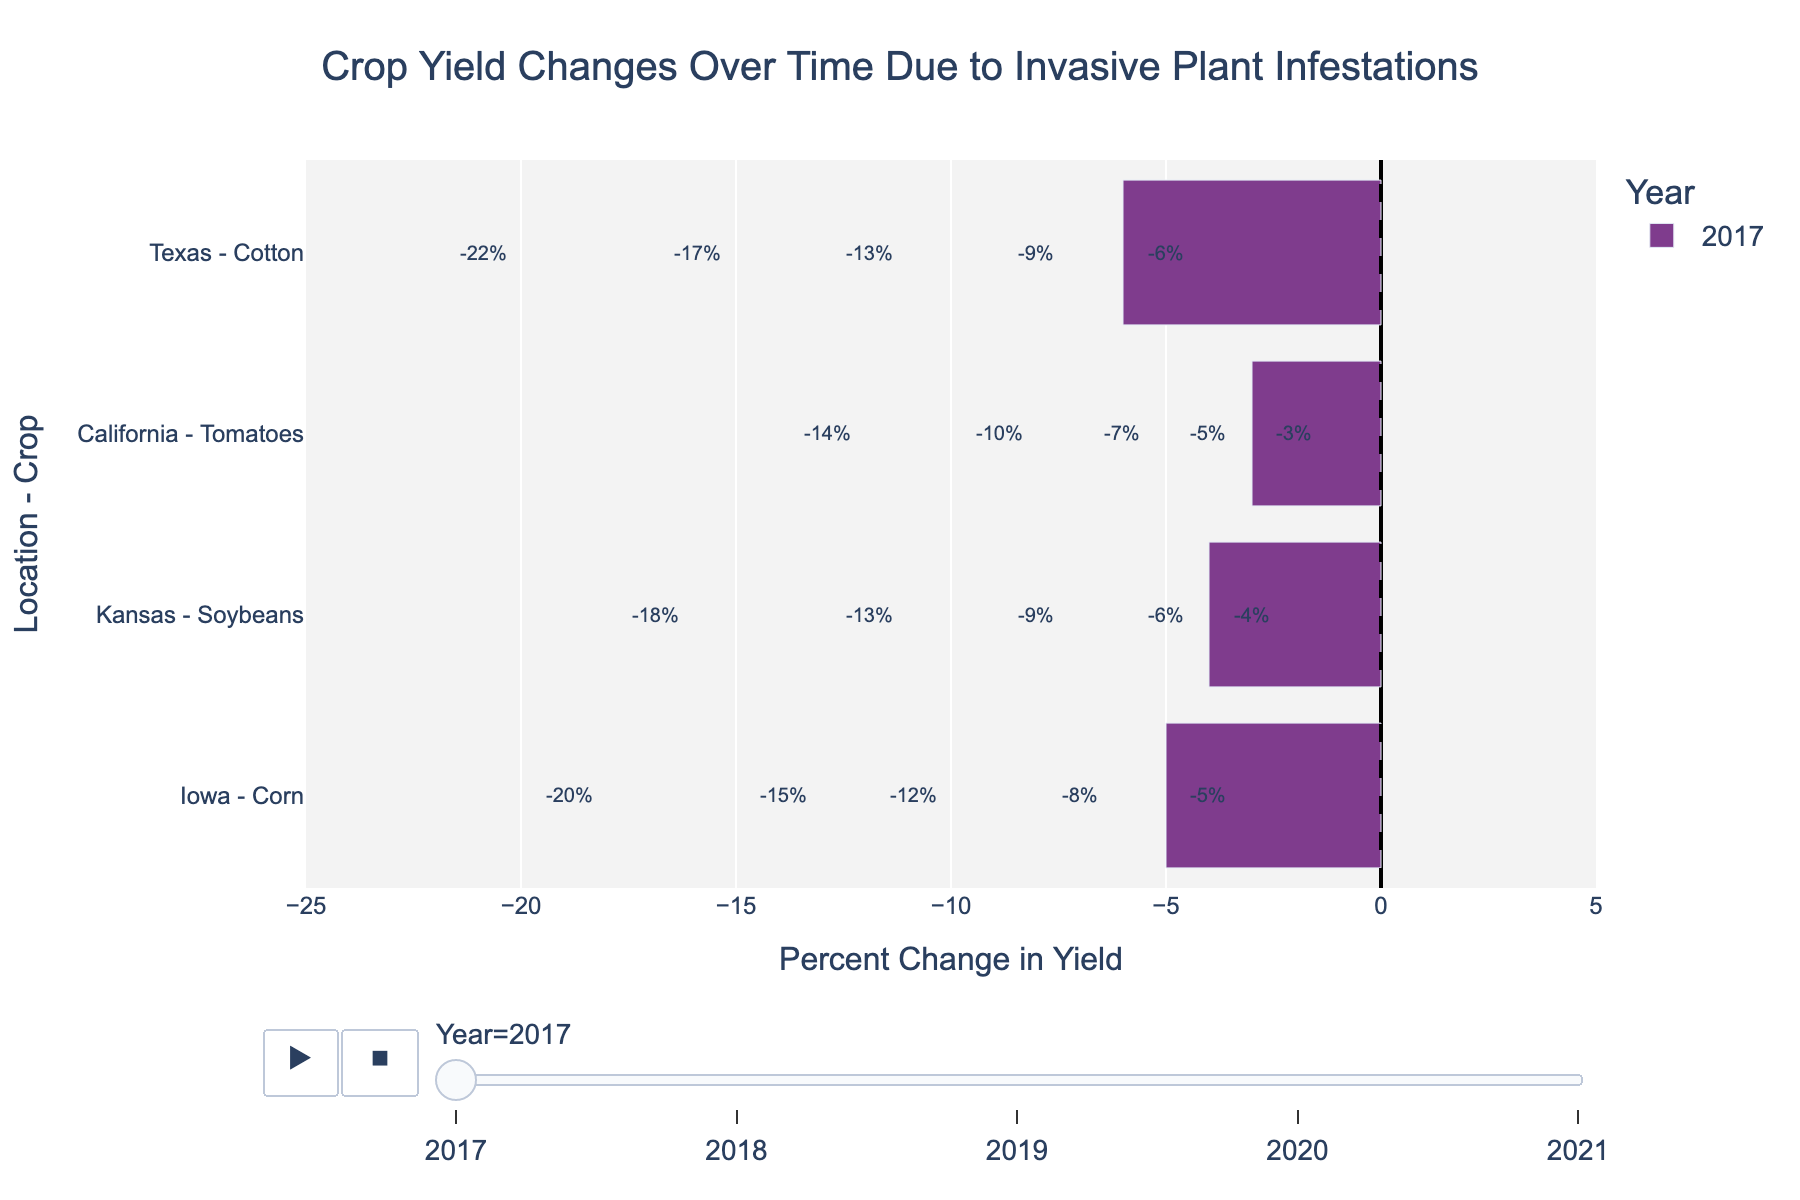What is the average percent change in yield for Iowa Corn between 2017 and 2021? To find the average, add the percent changes for each year and divide by the number of years. (-5) + (-8) + (-12) + (-15) + (-20) = -60. Then divide by 5, which gives -60 / 5 = -12
Answer: -12 Which crop experienced the greatest decline in yield in 2021? In 2021, Texas Cotton had a yield change of -22%, Iowa Corn had -20%, Kansas Soybeans had -18%, and California Tomatoes had -14%. The greatest decline occurred in Texas Cotton with -22%.
Answer: Texas Cotton Compare the percent change in yield for Kansas Soybeans and California Tomatoes in 2019. Which one experienced a larger decline? In 2019, Kansas Soybeans had a percent change in yield of -9%, while California Tomatoes had -7%. Kansas Soybeans experienced a larger decline.
Answer: Kansas Soybeans How much more did Texas Cotton decline compared to Iowa Corn in 2018? In 2018, Texas Cotton had a decline of -9% and Iowa Corn had -8%. The difference is -9% - (-8%) = -1%.
Answer: -1% Which crop had the smallest reduction in yield in 2017, and what was the percentage? In 2017, California Tomatoes had the smallest reduction with -3%.
Answer: California Tomatoes, -3% What is the trend of percent change in yield for Iowa Corn from 2017 to 2021? The percent changes for Iowa Corn are as follows: -5% (2017), -8% (2018), -12% (2019), -15% (2020), -20% (2021). The trend shows a steady decline year-over-year.
Answer: Steady decline How does the yield change of Kansas Soybeans in 2020 compare to the previous year? In 2019, Kansas Soybeans had a yield change of -9%, and in 2020, it was -13%. The yield decline increased by 4%.
Answer: Decline increased by 4% If you were to rank the crops by the total percent reduction in yield from 2017 to 2021, which crop would be the second most affected? Summing up the data from 2017 to 2021: Texas Cotton (-6, -9, -13, -17, -22 = -67), Iowa Corn (-5, -8, -12, -15, -20 = -60), Kansas Soybeans (-4, -6, -9, -13, -18 = -50), California Tomatoes (-3, -5, -7, -10, -14 = -39). Iowa Corn is the second most affected.
Answer: Iowa Corn What color represents the bar for the year 2020? The figure indicates year color coding using the "Bold" color palette, where 2020 is marked with a specific color (e.g., green). This color needs to be visually confirmed.
Answer: Visual confirmation needed Which location-crop combination in the figure represents the highest overall decline in percent change in yield? By looking at the data, Texas Cotton consistently has the highest absolute decline year by year, reaching -22% in 2021.
Answer: Texas Cotton 